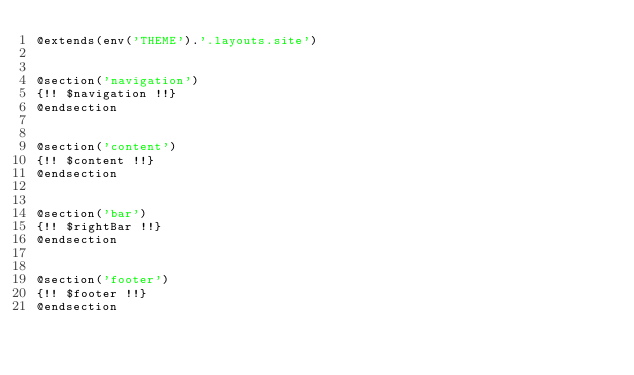<code> <loc_0><loc_0><loc_500><loc_500><_PHP_>@extends(env('THEME').'.layouts.site')


@section('navigation')
{!! $navigation !!}
@endsection 


@section('content')
{!! $content !!}
@endsection


@section('bar')
{!! $rightBar !!}
@endsection


@section('footer')
{!! $footer !!}
@endsection  </code> 